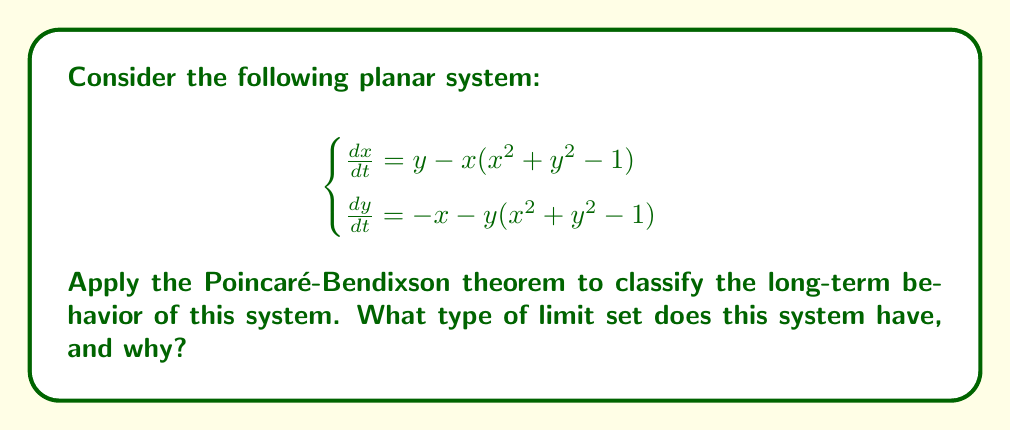Provide a solution to this math problem. To apply the Poincaré-Bendixson theorem and classify the long-term behavior of this system, we'll follow these steps:

1) First, let's identify the equilibrium points of the system. Set both equations to zero:

   $$\begin{cases}
   y - x(x^2 + y^2 - 1) = 0 \\
   -x - y(x^2 + y^2 - 1) = 0
   \end{cases}$$

2) By inspection, we can see that $(0,0)$ is an equilibrium point. To find others, we can multiply the first equation by $x$ and the second by $y$ and add them:

   $$xy - x^2(x^2 + y^2 - 1) - xy - y^2(x^2 + y^2 - 1) = 0$$
   $$-(x^2 + y^2)(x^2 + y^2 - 1) = 0$$

3) This equation is satisfied when $x^2 + y^2 = 1$, which represents a circle of radius 1 centered at the origin. All points on this circle are equilibrium points.

4) Now, let's consider the behavior of trajectories:
   - Inside the unit circle ($x^2 + y^2 < 1$), we have $\frac{d}{dt}(x^2 + y^2) > 0$
   - Outside the unit circle ($x^2 + y^2 > 1$), we have $\frac{d}{dt}(x^2 + y^2) < 0$

5) This means that trajectories spiral outward inside the unit circle and spiral inward outside the unit circle.

6) The Poincaré-Bendixson theorem states that for a bounded planar system, if a trajectory enters and remains in a closed, bounded region that contains no equilibrium points, then the trajectory must approach a closed orbit.

7) In this case, we have a closed, bounded region (the unit circle) that contains no equilibrium points in its interior (except the origin). Trajectories from both inside and outside the circle approach this closed orbit.

8) Therefore, the unit circle itself ($x^2 + y^2 = 1$) is a limit cycle for this system.
Answer: The system has a limit cycle at $x^2 + y^2 = 1$. 